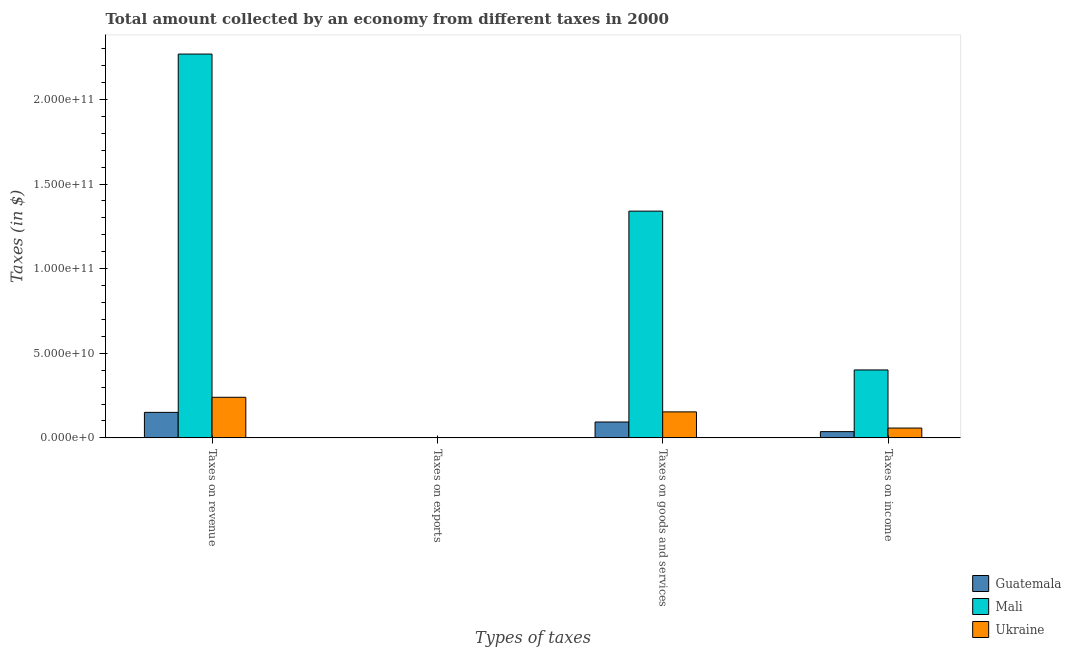How many groups of bars are there?
Make the answer very short. 4. Are the number of bars per tick equal to the number of legend labels?
Your response must be concise. Yes. What is the label of the 2nd group of bars from the left?
Ensure brevity in your answer.  Taxes on exports. What is the amount collected as tax on revenue in Guatemala?
Provide a short and direct response. 1.51e+1. Across all countries, what is the maximum amount collected as tax on income?
Offer a very short reply. 4.01e+1. Across all countries, what is the minimum amount collected as tax on exports?
Your response must be concise. 2.89e+05. In which country was the amount collected as tax on goods maximum?
Offer a very short reply. Mali. In which country was the amount collected as tax on revenue minimum?
Make the answer very short. Guatemala. What is the total amount collected as tax on revenue in the graph?
Your response must be concise. 2.66e+11. What is the difference between the amount collected as tax on goods in Ukraine and that in Guatemala?
Make the answer very short. 5.99e+09. What is the difference between the amount collected as tax on income in Guatemala and the amount collected as tax on goods in Mali?
Offer a very short reply. -1.30e+11. What is the average amount collected as tax on income per country?
Offer a very short reply. 1.65e+1. What is the difference between the amount collected as tax on exports and amount collected as tax on income in Guatemala?
Provide a succinct answer. -3.69e+09. In how many countries, is the amount collected as tax on revenue greater than 60000000000 $?
Ensure brevity in your answer.  1. What is the ratio of the amount collected as tax on revenue in Mali to that in Ukraine?
Give a very brief answer. 9.46. Is the difference between the amount collected as tax on exports in Ukraine and Mali greater than the difference between the amount collected as tax on goods in Ukraine and Mali?
Make the answer very short. Yes. What is the difference between the highest and the second highest amount collected as tax on goods?
Make the answer very short. 1.19e+11. What is the difference between the highest and the lowest amount collected as tax on revenue?
Your response must be concise. 2.12e+11. In how many countries, is the amount collected as tax on revenue greater than the average amount collected as tax on revenue taken over all countries?
Provide a short and direct response. 1. Is the sum of the amount collected as tax on exports in Mali and Guatemala greater than the maximum amount collected as tax on revenue across all countries?
Provide a short and direct response. No. What does the 2nd bar from the left in Taxes on goods and services represents?
Offer a very short reply. Mali. What does the 3rd bar from the right in Taxes on revenue represents?
Offer a very short reply. Guatemala. Is it the case that in every country, the sum of the amount collected as tax on revenue and amount collected as tax on exports is greater than the amount collected as tax on goods?
Keep it short and to the point. Yes. Are all the bars in the graph horizontal?
Your answer should be compact. No. How many countries are there in the graph?
Ensure brevity in your answer.  3. What is the difference between two consecutive major ticks on the Y-axis?
Provide a succinct answer. 5.00e+1. How many legend labels are there?
Your answer should be compact. 3. How are the legend labels stacked?
Give a very brief answer. Vertical. What is the title of the graph?
Give a very brief answer. Total amount collected by an economy from different taxes in 2000. What is the label or title of the X-axis?
Give a very brief answer. Types of taxes. What is the label or title of the Y-axis?
Your response must be concise. Taxes (in $). What is the Taxes (in $) of Guatemala in Taxes on revenue?
Provide a short and direct response. 1.51e+1. What is the Taxes (in $) in Mali in Taxes on revenue?
Your response must be concise. 2.27e+11. What is the Taxes (in $) in Ukraine in Taxes on revenue?
Provide a succinct answer. 2.40e+1. What is the Taxes (in $) in Guatemala in Taxes on exports?
Provide a short and direct response. 1.49e+06. What is the Taxes (in $) in Mali in Taxes on exports?
Keep it short and to the point. 2.89e+05. What is the Taxes (in $) in Ukraine in Taxes on exports?
Your answer should be very brief. 5.60e+06. What is the Taxes (in $) in Guatemala in Taxes on goods and services?
Your response must be concise. 9.38e+09. What is the Taxes (in $) of Mali in Taxes on goods and services?
Give a very brief answer. 1.34e+11. What is the Taxes (in $) in Ukraine in Taxes on goods and services?
Provide a succinct answer. 1.54e+1. What is the Taxes (in $) of Guatemala in Taxes on income?
Offer a very short reply. 3.69e+09. What is the Taxes (in $) of Mali in Taxes on income?
Keep it short and to the point. 4.01e+1. What is the Taxes (in $) of Ukraine in Taxes on income?
Offer a very short reply. 5.80e+09. Across all Types of taxes, what is the maximum Taxes (in $) in Guatemala?
Keep it short and to the point. 1.51e+1. Across all Types of taxes, what is the maximum Taxes (in $) in Mali?
Give a very brief answer. 2.27e+11. Across all Types of taxes, what is the maximum Taxes (in $) in Ukraine?
Give a very brief answer. 2.40e+1. Across all Types of taxes, what is the minimum Taxes (in $) of Guatemala?
Provide a succinct answer. 1.49e+06. Across all Types of taxes, what is the minimum Taxes (in $) of Mali?
Ensure brevity in your answer.  2.89e+05. Across all Types of taxes, what is the minimum Taxes (in $) in Ukraine?
Keep it short and to the point. 5.60e+06. What is the total Taxes (in $) of Guatemala in the graph?
Ensure brevity in your answer.  2.81e+1. What is the total Taxes (in $) in Mali in the graph?
Provide a succinct answer. 4.01e+11. What is the total Taxes (in $) in Ukraine in the graph?
Provide a succinct answer. 4.52e+1. What is the difference between the Taxes (in $) of Guatemala in Taxes on revenue and that in Taxes on exports?
Your answer should be very brief. 1.51e+1. What is the difference between the Taxes (in $) in Mali in Taxes on revenue and that in Taxes on exports?
Provide a succinct answer. 2.27e+11. What is the difference between the Taxes (in $) in Ukraine in Taxes on revenue and that in Taxes on exports?
Make the answer very short. 2.40e+1. What is the difference between the Taxes (in $) of Guatemala in Taxes on revenue and that in Taxes on goods and services?
Your answer should be very brief. 5.70e+09. What is the difference between the Taxes (in $) of Mali in Taxes on revenue and that in Taxes on goods and services?
Offer a very short reply. 9.28e+1. What is the difference between the Taxes (in $) in Ukraine in Taxes on revenue and that in Taxes on goods and services?
Make the answer very short. 8.62e+09. What is the difference between the Taxes (in $) of Guatemala in Taxes on revenue and that in Taxes on income?
Keep it short and to the point. 1.14e+1. What is the difference between the Taxes (in $) of Mali in Taxes on revenue and that in Taxes on income?
Ensure brevity in your answer.  1.87e+11. What is the difference between the Taxes (in $) in Ukraine in Taxes on revenue and that in Taxes on income?
Keep it short and to the point. 1.82e+1. What is the difference between the Taxes (in $) in Guatemala in Taxes on exports and that in Taxes on goods and services?
Your answer should be compact. -9.37e+09. What is the difference between the Taxes (in $) in Mali in Taxes on exports and that in Taxes on goods and services?
Offer a terse response. -1.34e+11. What is the difference between the Taxes (in $) in Ukraine in Taxes on exports and that in Taxes on goods and services?
Your answer should be compact. -1.54e+1. What is the difference between the Taxes (in $) in Guatemala in Taxes on exports and that in Taxes on income?
Your response must be concise. -3.69e+09. What is the difference between the Taxes (in $) of Mali in Taxes on exports and that in Taxes on income?
Ensure brevity in your answer.  -4.01e+1. What is the difference between the Taxes (in $) of Ukraine in Taxes on exports and that in Taxes on income?
Provide a short and direct response. -5.80e+09. What is the difference between the Taxes (in $) of Guatemala in Taxes on goods and services and that in Taxes on income?
Your answer should be very brief. 5.69e+09. What is the difference between the Taxes (in $) of Mali in Taxes on goods and services and that in Taxes on income?
Provide a succinct answer. 9.39e+1. What is the difference between the Taxes (in $) in Ukraine in Taxes on goods and services and that in Taxes on income?
Offer a terse response. 9.56e+09. What is the difference between the Taxes (in $) in Guatemala in Taxes on revenue and the Taxes (in $) in Mali in Taxes on exports?
Give a very brief answer. 1.51e+1. What is the difference between the Taxes (in $) in Guatemala in Taxes on revenue and the Taxes (in $) in Ukraine in Taxes on exports?
Your answer should be compact. 1.51e+1. What is the difference between the Taxes (in $) in Mali in Taxes on revenue and the Taxes (in $) in Ukraine in Taxes on exports?
Your answer should be compact. 2.27e+11. What is the difference between the Taxes (in $) in Guatemala in Taxes on revenue and the Taxes (in $) in Mali in Taxes on goods and services?
Give a very brief answer. -1.19e+11. What is the difference between the Taxes (in $) of Guatemala in Taxes on revenue and the Taxes (in $) of Ukraine in Taxes on goods and services?
Make the answer very short. -2.90e+08. What is the difference between the Taxes (in $) in Mali in Taxes on revenue and the Taxes (in $) in Ukraine in Taxes on goods and services?
Keep it short and to the point. 2.11e+11. What is the difference between the Taxes (in $) in Guatemala in Taxes on revenue and the Taxes (in $) in Mali in Taxes on income?
Offer a very short reply. -2.51e+1. What is the difference between the Taxes (in $) in Guatemala in Taxes on revenue and the Taxes (in $) in Ukraine in Taxes on income?
Keep it short and to the point. 9.27e+09. What is the difference between the Taxes (in $) in Mali in Taxes on revenue and the Taxes (in $) in Ukraine in Taxes on income?
Your response must be concise. 2.21e+11. What is the difference between the Taxes (in $) of Guatemala in Taxes on exports and the Taxes (in $) of Mali in Taxes on goods and services?
Your answer should be very brief. -1.34e+11. What is the difference between the Taxes (in $) of Guatemala in Taxes on exports and the Taxes (in $) of Ukraine in Taxes on goods and services?
Provide a short and direct response. -1.54e+1. What is the difference between the Taxes (in $) in Mali in Taxes on exports and the Taxes (in $) in Ukraine in Taxes on goods and services?
Provide a succinct answer. -1.54e+1. What is the difference between the Taxes (in $) in Guatemala in Taxes on exports and the Taxes (in $) in Mali in Taxes on income?
Your response must be concise. -4.01e+1. What is the difference between the Taxes (in $) of Guatemala in Taxes on exports and the Taxes (in $) of Ukraine in Taxes on income?
Provide a short and direct response. -5.80e+09. What is the difference between the Taxes (in $) in Mali in Taxes on exports and the Taxes (in $) in Ukraine in Taxes on income?
Your response must be concise. -5.80e+09. What is the difference between the Taxes (in $) of Guatemala in Taxes on goods and services and the Taxes (in $) of Mali in Taxes on income?
Offer a terse response. -3.08e+1. What is the difference between the Taxes (in $) in Guatemala in Taxes on goods and services and the Taxes (in $) in Ukraine in Taxes on income?
Your answer should be very brief. 3.57e+09. What is the difference between the Taxes (in $) of Mali in Taxes on goods and services and the Taxes (in $) of Ukraine in Taxes on income?
Make the answer very short. 1.28e+11. What is the average Taxes (in $) in Guatemala per Types of taxes?
Make the answer very short. 7.03e+09. What is the average Taxes (in $) in Mali per Types of taxes?
Give a very brief answer. 1.00e+11. What is the average Taxes (in $) of Ukraine per Types of taxes?
Keep it short and to the point. 1.13e+1. What is the difference between the Taxes (in $) in Guatemala and Taxes (in $) in Mali in Taxes on revenue?
Offer a very short reply. -2.12e+11. What is the difference between the Taxes (in $) of Guatemala and Taxes (in $) of Ukraine in Taxes on revenue?
Provide a succinct answer. -8.91e+09. What is the difference between the Taxes (in $) of Mali and Taxes (in $) of Ukraine in Taxes on revenue?
Offer a terse response. 2.03e+11. What is the difference between the Taxes (in $) in Guatemala and Taxes (in $) in Mali in Taxes on exports?
Give a very brief answer. 1.20e+06. What is the difference between the Taxes (in $) of Guatemala and Taxes (in $) of Ukraine in Taxes on exports?
Your answer should be compact. -4.11e+06. What is the difference between the Taxes (in $) in Mali and Taxes (in $) in Ukraine in Taxes on exports?
Ensure brevity in your answer.  -5.31e+06. What is the difference between the Taxes (in $) in Guatemala and Taxes (in $) in Mali in Taxes on goods and services?
Your answer should be very brief. -1.25e+11. What is the difference between the Taxes (in $) in Guatemala and Taxes (in $) in Ukraine in Taxes on goods and services?
Offer a very short reply. -5.99e+09. What is the difference between the Taxes (in $) in Mali and Taxes (in $) in Ukraine in Taxes on goods and services?
Offer a very short reply. 1.19e+11. What is the difference between the Taxes (in $) of Guatemala and Taxes (in $) of Mali in Taxes on income?
Offer a very short reply. -3.65e+1. What is the difference between the Taxes (in $) in Guatemala and Taxes (in $) in Ukraine in Taxes on income?
Offer a terse response. -2.11e+09. What is the difference between the Taxes (in $) in Mali and Taxes (in $) in Ukraine in Taxes on income?
Provide a short and direct response. 3.43e+1. What is the ratio of the Taxes (in $) of Guatemala in Taxes on revenue to that in Taxes on exports?
Give a very brief answer. 1.01e+04. What is the ratio of the Taxes (in $) in Mali in Taxes on revenue to that in Taxes on exports?
Your answer should be compact. 7.85e+05. What is the ratio of the Taxes (in $) of Ukraine in Taxes on revenue to that in Taxes on exports?
Make the answer very short. 4282.23. What is the ratio of the Taxes (in $) of Guatemala in Taxes on revenue to that in Taxes on goods and services?
Offer a terse response. 1.61. What is the ratio of the Taxes (in $) in Mali in Taxes on revenue to that in Taxes on goods and services?
Offer a terse response. 1.69. What is the ratio of the Taxes (in $) of Ukraine in Taxes on revenue to that in Taxes on goods and services?
Make the answer very short. 1.56. What is the ratio of the Taxes (in $) in Guatemala in Taxes on revenue to that in Taxes on income?
Your answer should be very brief. 4.09. What is the ratio of the Taxes (in $) in Mali in Taxes on revenue to that in Taxes on income?
Provide a succinct answer. 5.65. What is the ratio of the Taxes (in $) in Ukraine in Taxes on revenue to that in Taxes on income?
Keep it short and to the point. 4.13. What is the ratio of the Taxes (in $) of Mali in Taxes on exports to that in Taxes on goods and services?
Your response must be concise. 0. What is the ratio of the Taxes (in $) in Guatemala in Taxes on exports to that in Taxes on income?
Ensure brevity in your answer.  0. What is the ratio of the Taxes (in $) in Ukraine in Taxes on exports to that in Taxes on income?
Give a very brief answer. 0. What is the ratio of the Taxes (in $) in Guatemala in Taxes on goods and services to that in Taxes on income?
Keep it short and to the point. 2.54. What is the ratio of the Taxes (in $) of Mali in Taxes on goods and services to that in Taxes on income?
Offer a terse response. 3.34. What is the ratio of the Taxes (in $) in Ukraine in Taxes on goods and services to that in Taxes on income?
Your answer should be compact. 2.65. What is the difference between the highest and the second highest Taxes (in $) in Guatemala?
Your response must be concise. 5.70e+09. What is the difference between the highest and the second highest Taxes (in $) of Mali?
Provide a succinct answer. 9.28e+1. What is the difference between the highest and the second highest Taxes (in $) in Ukraine?
Provide a succinct answer. 8.62e+09. What is the difference between the highest and the lowest Taxes (in $) in Guatemala?
Ensure brevity in your answer.  1.51e+1. What is the difference between the highest and the lowest Taxes (in $) in Mali?
Offer a terse response. 2.27e+11. What is the difference between the highest and the lowest Taxes (in $) in Ukraine?
Offer a very short reply. 2.40e+1. 